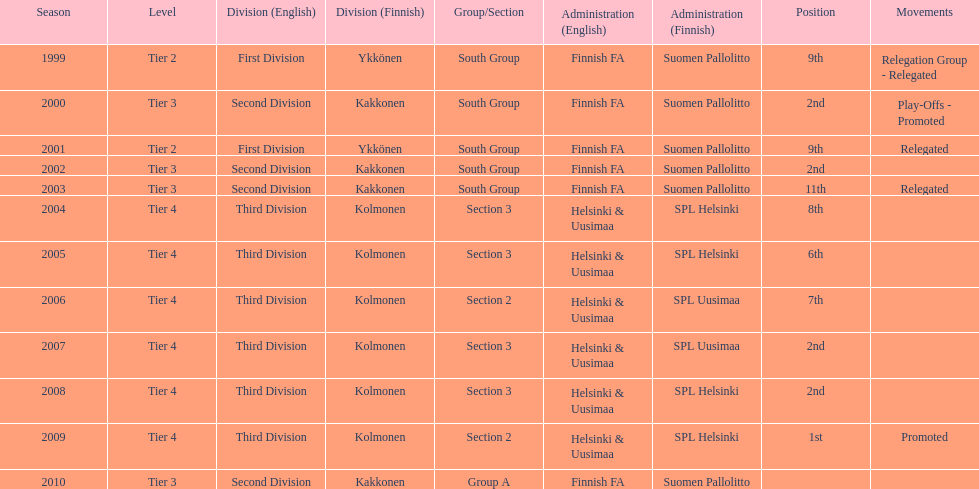What is the first tier listed? Tier 2. 